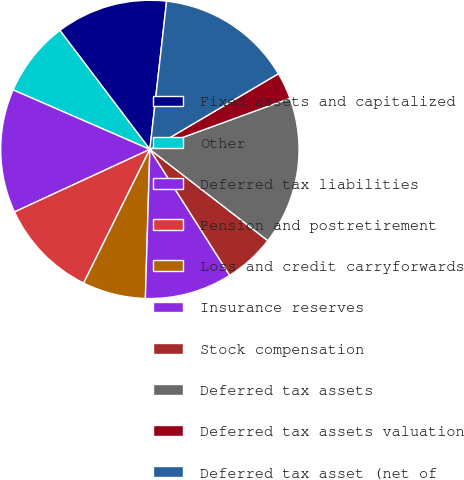Convert chart. <chart><loc_0><loc_0><loc_500><loc_500><pie_chart><fcel>Fixed assets and capitalized<fcel>Other<fcel>Deferred tax liabilities<fcel>Pension and postretirement<fcel>Loss and credit carryforwards<fcel>Insurance reserves<fcel>Stock compensation<fcel>Deferred tax assets<fcel>Deferred tax assets valuation<fcel>Deferred tax asset (net of<nl><fcel>12.1%<fcel>8.16%<fcel>13.42%<fcel>10.79%<fcel>6.84%<fcel>9.47%<fcel>5.53%<fcel>16.05%<fcel>2.9%<fcel>14.74%<nl></chart> 